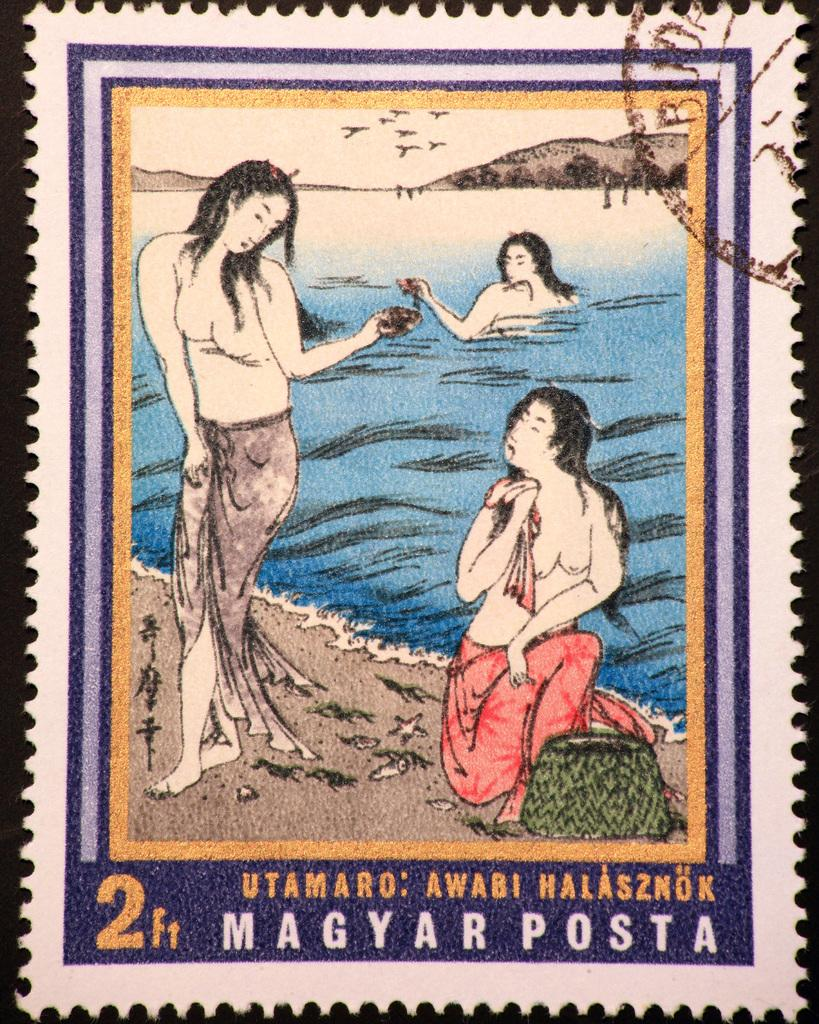What type of image is being described? The image is a postage stamp. How many women are depicted in the image? There are two women in the image. What is the woman in the background doing? The woman in the background is in the water. What can be seen in the distance behind the women? Mountains and birds flying in the sky are visible in the background. What type of church can be seen in the image? There is no church present in the image; it is a postage stamp featuring two women and a woman in the water, with mountains and birds in the background. 